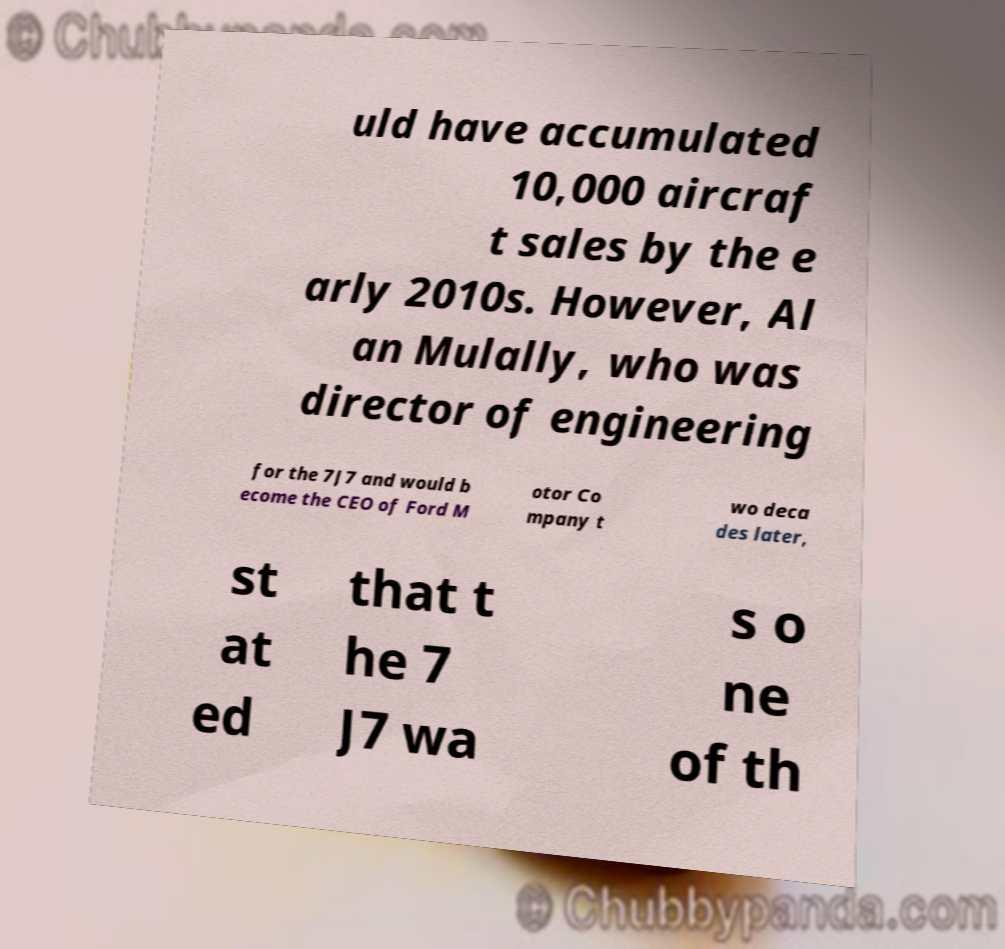There's text embedded in this image that I need extracted. Can you transcribe it verbatim? uld have accumulated 10,000 aircraf t sales by the e arly 2010s. However, Al an Mulally, who was director of engineering for the 7J7 and would b ecome the CEO of Ford M otor Co mpany t wo deca des later, st at ed that t he 7 J7 wa s o ne of th 